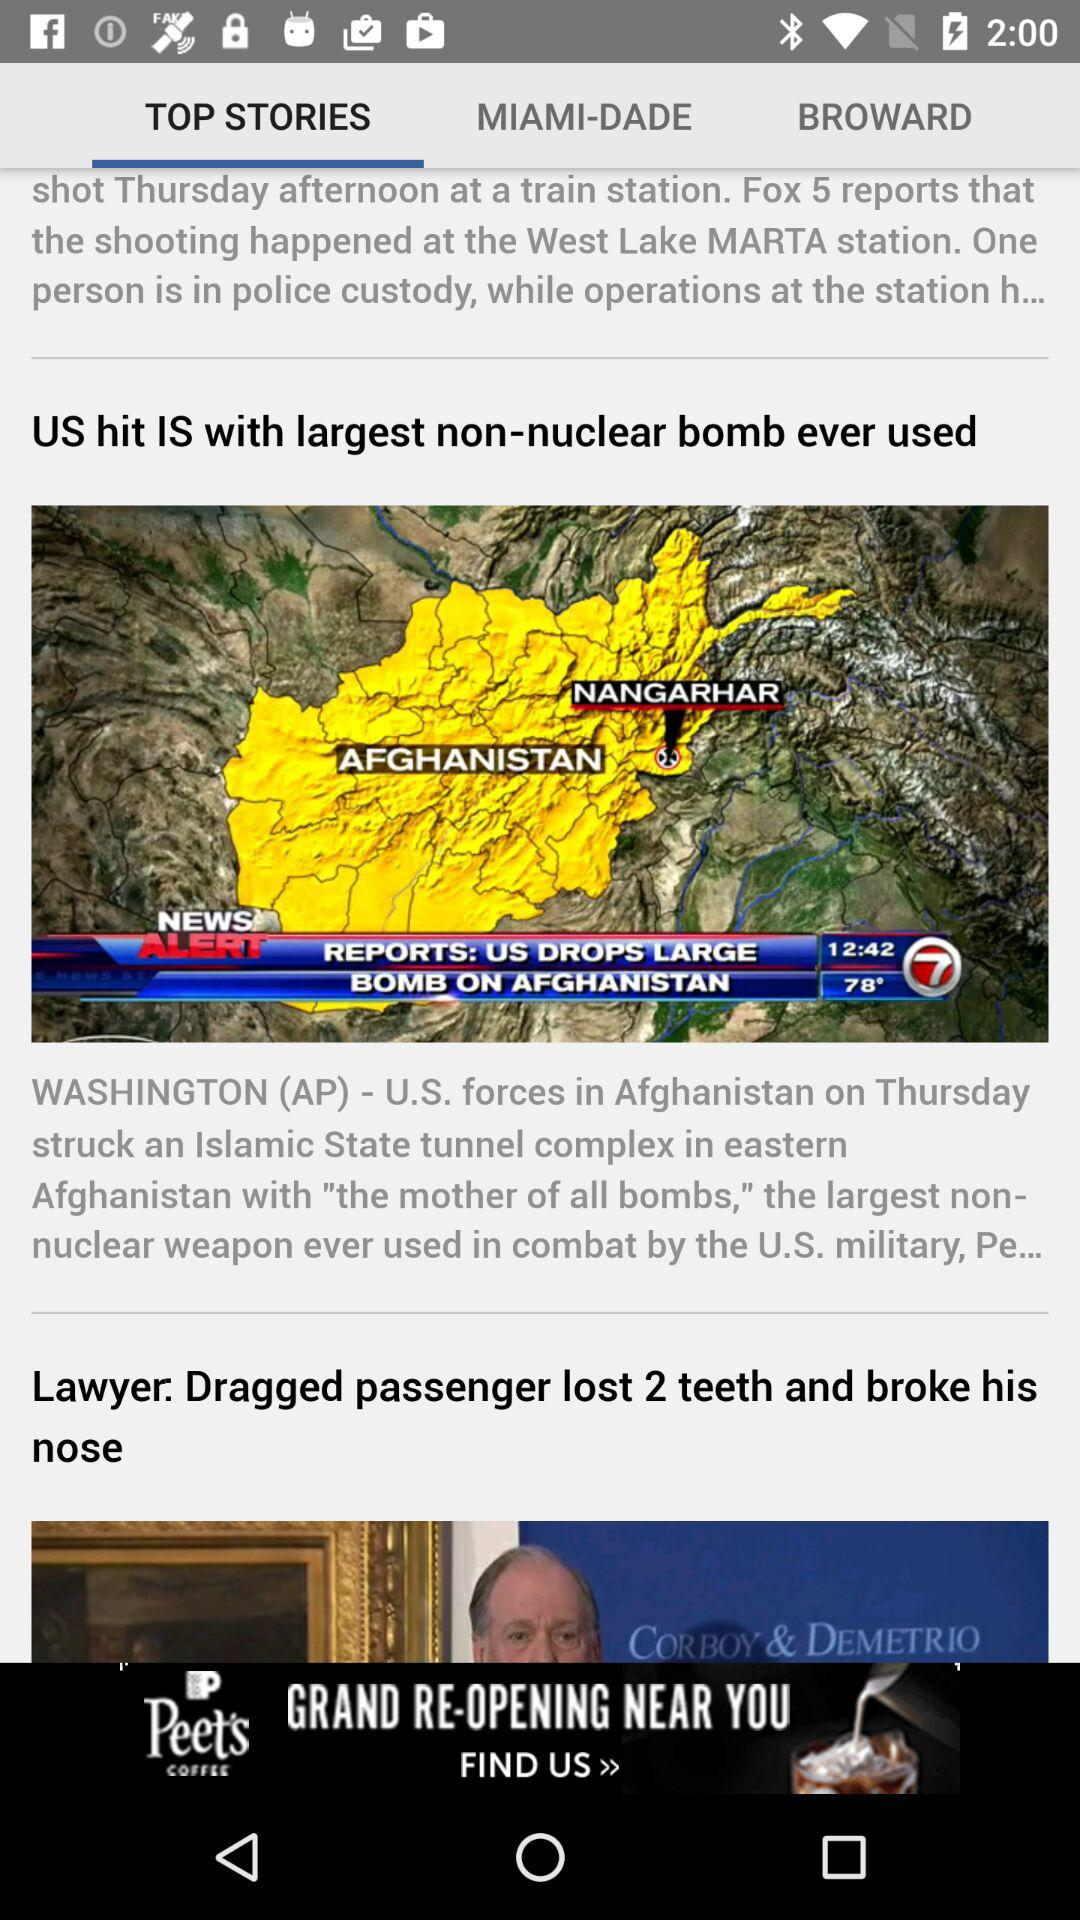Which tab is selected? The selected tab is "TOP STORIES". 